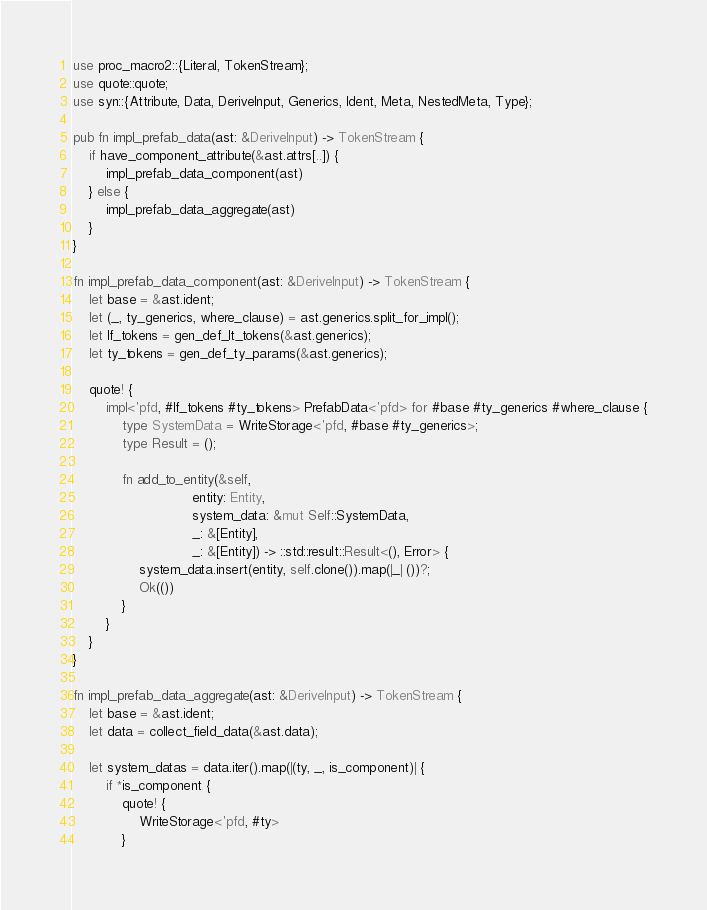Convert code to text. <code><loc_0><loc_0><loc_500><loc_500><_Rust_>use proc_macro2::{Literal, TokenStream};
use quote::quote;
use syn::{Attribute, Data, DeriveInput, Generics, Ident, Meta, NestedMeta, Type};

pub fn impl_prefab_data(ast: &DeriveInput) -> TokenStream {
    if have_component_attribute(&ast.attrs[..]) {
        impl_prefab_data_component(ast)
    } else {
        impl_prefab_data_aggregate(ast)
    }
}

fn impl_prefab_data_component(ast: &DeriveInput) -> TokenStream {
    let base = &ast.ident;
    let (_, ty_generics, where_clause) = ast.generics.split_for_impl();
    let lf_tokens = gen_def_lt_tokens(&ast.generics);
    let ty_tokens = gen_def_ty_params(&ast.generics);

    quote! {
        impl<'pfd, #lf_tokens #ty_tokens> PrefabData<'pfd> for #base #ty_generics #where_clause {
            type SystemData = WriteStorage<'pfd, #base #ty_generics>;
            type Result = ();

            fn add_to_entity(&self,
                             entity: Entity,
                             system_data: &mut Self::SystemData,
                             _: &[Entity],
                             _: &[Entity]) -> ::std::result::Result<(), Error> {
                system_data.insert(entity, self.clone()).map(|_| ())?;
                Ok(())
            }
        }
    }
}

fn impl_prefab_data_aggregate(ast: &DeriveInput) -> TokenStream {
    let base = &ast.ident;
    let data = collect_field_data(&ast.data);

    let system_datas = data.iter().map(|(ty, _, is_component)| {
        if *is_component {
            quote! {
                WriteStorage<'pfd, #ty>
            }</code> 